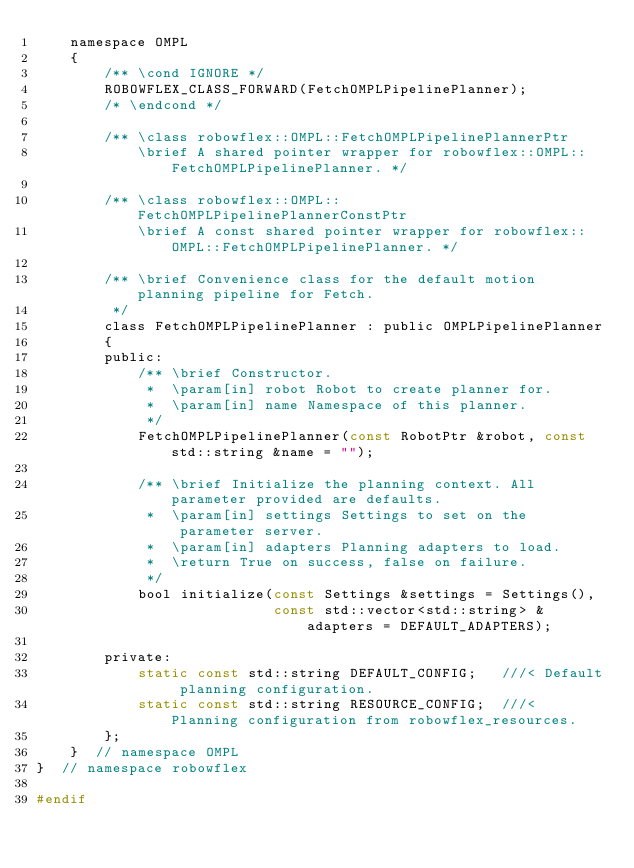<code> <loc_0><loc_0><loc_500><loc_500><_C_>    namespace OMPL
    {
        /** \cond IGNORE */
        ROBOWFLEX_CLASS_FORWARD(FetchOMPLPipelinePlanner);
        /* \endcond */

        /** \class robowflex::OMPL::FetchOMPLPipelinePlannerPtr
            \brief A shared pointer wrapper for robowflex::OMPL::FetchOMPLPipelinePlanner. */

        /** \class robowflex::OMPL::FetchOMPLPipelinePlannerConstPtr
            \brief A const shared pointer wrapper for robowflex::OMPL::FetchOMPLPipelinePlanner. */

        /** \brief Convenience class for the default motion planning pipeline for Fetch.
         */
        class FetchOMPLPipelinePlanner : public OMPLPipelinePlanner
        {
        public:
            /** \brief Constructor.
             *  \param[in] robot Robot to create planner for.
             *  \param[in] name Namespace of this planner.
             */
            FetchOMPLPipelinePlanner(const RobotPtr &robot, const std::string &name = "");

            /** \brief Initialize the planning context. All parameter provided are defaults.
             *  \param[in] settings Settings to set on the parameter server.
             *  \param[in] adapters Planning adapters to load.
             *  \return True on success, false on failure.
             */
            bool initialize(const Settings &settings = Settings(),
                            const std::vector<std::string> &adapters = DEFAULT_ADAPTERS);

        private:
            static const std::string DEFAULT_CONFIG;   ///< Default planning configuration.
            static const std::string RESOURCE_CONFIG;  ///< Planning configuration from robowflex_resources.
        };
    }  // namespace OMPL
}  // namespace robowflex

#endif
</code> 